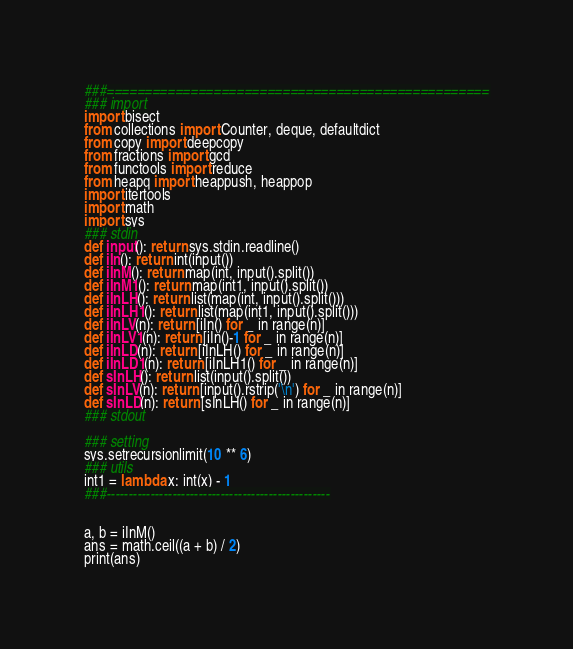Convert code to text. <code><loc_0><loc_0><loc_500><loc_500><_Python_>###==================================================
### import
import bisect
from collections import Counter, deque, defaultdict
from copy import deepcopy
from fractions import gcd
from functools import reduce
from heapq import heappush, heappop
import itertools
import math
import sys
### stdin
def input(): return sys.stdin.readline()
def iIn(): return int(input())
def iInM(): return map(int, input().split())
def iInM1(): return map(int1, input().split())
def iInLH(): return list(map(int, input().split()))
def iInLH1(): return list(map(int1, input().split()))
def iInLV(n): return [iIn() for _ in range(n)]
def iInLV1(n): return [iIn()-1 for _ in range(n)]
def iInLD(n): return [iInLH() for _ in range(n)]
def iInLD1(n): return [iInLH1() for _ in range(n)]
def sInLH(): return list(input().split())
def sInLV(n): return [input().rstrip('\n') for _ in range(n)]
def sInLD(n): return [sInLH() for _ in range(n)]
### stdout

### setting
sys.setrecursionlimit(10 ** 6)
### utils
int1 = lambda x: int(x) - 1
###---------------------------------------------------


a, b = iInM()
ans = math.ceil((a + b) / 2)
print(ans)

</code> 